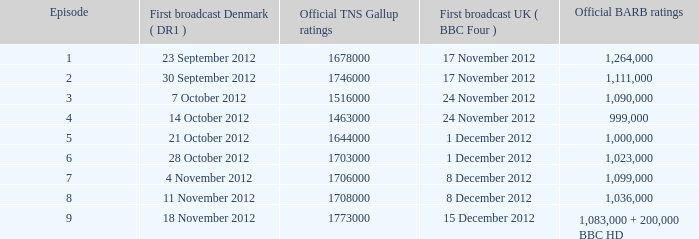When was the episode with a 1,036,000 BARB rating first aired in Denmark? 11 November 2012. I'm looking to parse the entire table for insights. Could you assist me with that? {'header': ['Episode', 'First broadcast Denmark ( DR1 )', 'Official TNS Gallup ratings', 'First broadcast UK ( BBC Four )', 'Official BARB ratings'], 'rows': [['1', '23 September 2012', '1678000', '17 November 2012', '1,264,000'], ['2', '30 September 2012', '1746000', '17 November 2012', '1,111,000'], ['3', '7 October 2012', '1516000', '24 November 2012', '1,090,000'], ['4', '14 October 2012', '1463000', '24 November 2012', '999,000'], ['5', '21 October 2012', '1644000', '1 December 2012', '1,000,000'], ['6', '28 October 2012', '1703000', '1 December 2012', '1,023,000'], ['7', '4 November 2012', '1706000', '8 December 2012', '1,099,000'], ['8', '11 November 2012', '1708000', '8 December 2012', '1,036,000'], ['9', '18 November 2012', '1773000', '15 December 2012', '1,083,000 + 200,000 BBC HD']]} 